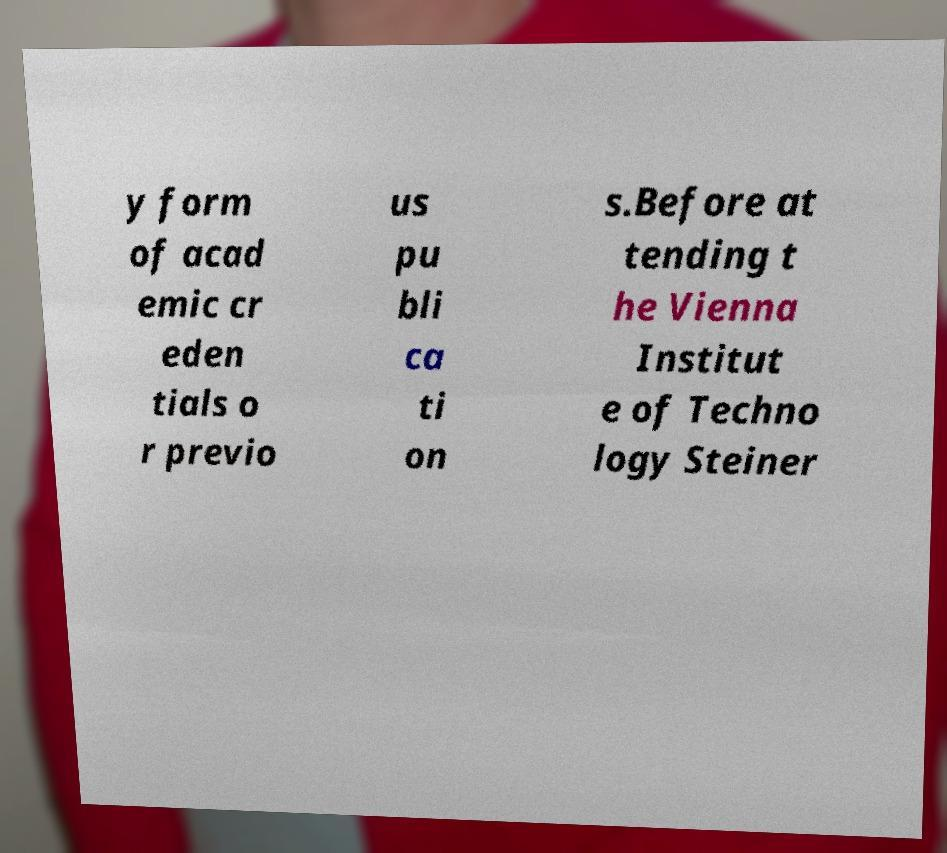There's text embedded in this image that I need extracted. Can you transcribe it verbatim? y form of acad emic cr eden tials o r previo us pu bli ca ti on s.Before at tending t he Vienna Institut e of Techno logy Steiner 